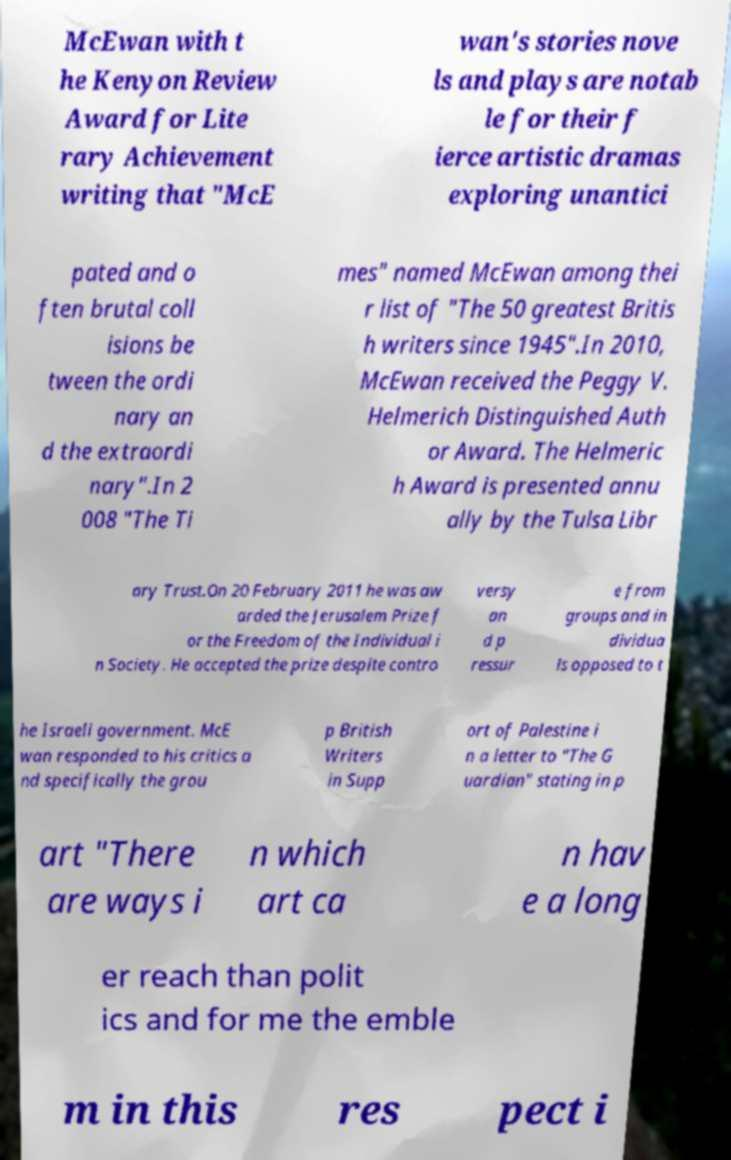Please read and relay the text visible in this image. What does it say? McEwan with t he Kenyon Review Award for Lite rary Achievement writing that "McE wan's stories nove ls and plays are notab le for their f ierce artistic dramas exploring unantici pated and o ften brutal coll isions be tween the ordi nary an d the extraordi nary".In 2 008 "The Ti mes" named McEwan among thei r list of "The 50 greatest Britis h writers since 1945".In 2010, McEwan received the Peggy V. Helmerich Distinguished Auth or Award. The Helmeric h Award is presented annu ally by the Tulsa Libr ary Trust.On 20 February 2011 he was aw arded the Jerusalem Prize f or the Freedom of the Individual i n Society. He accepted the prize despite contro versy an d p ressur e from groups and in dividua ls opposed to t he Israeli government. McE wan responded to his critics a nd specifically the grou p British Writers in Supp ort of Palestine i n a letter to "The G uardian" stating in p art "There are ways i n which art ca n hav e a long er reach than polit ics and for me the emble m in this res pect i 